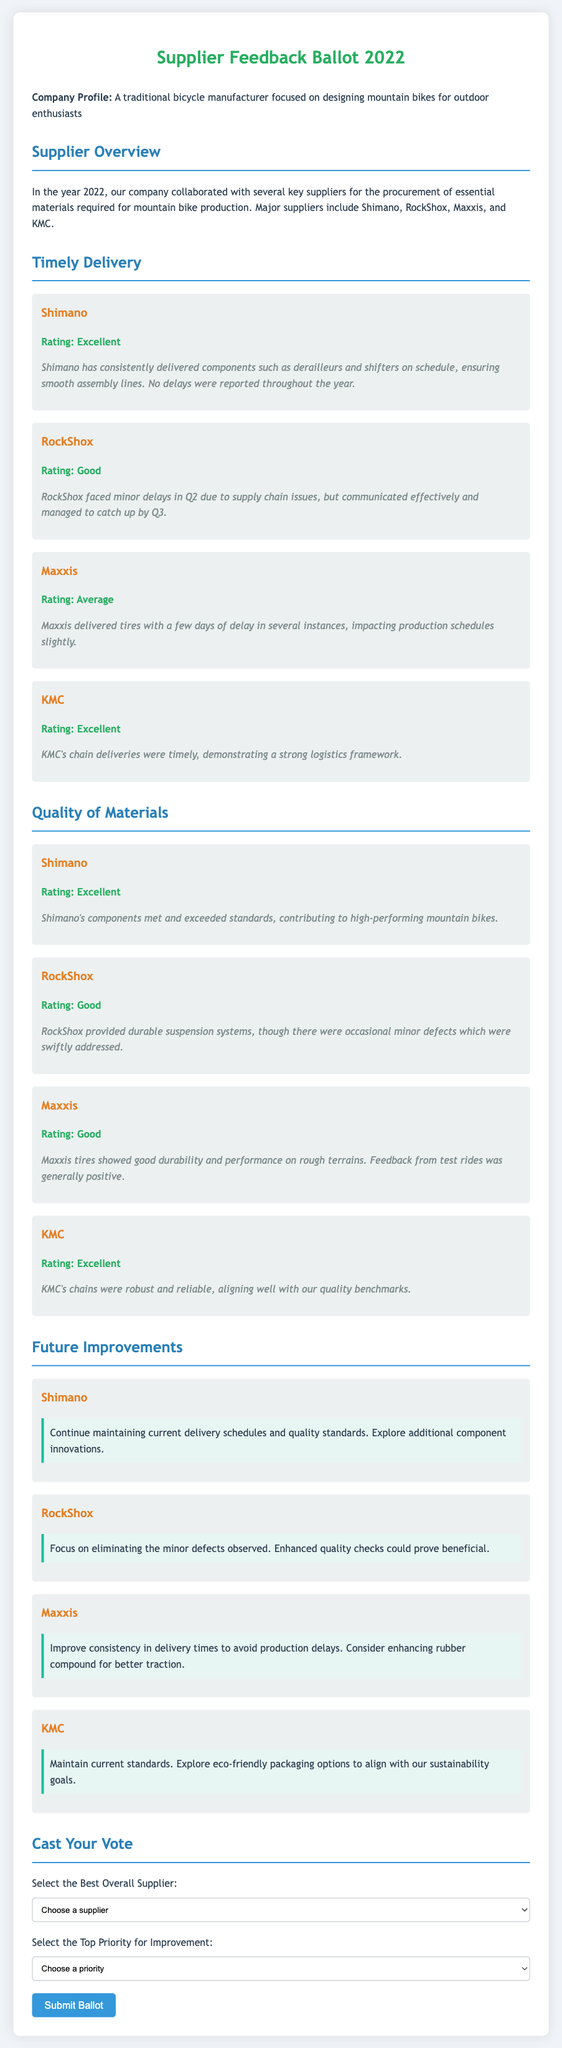what is the title of the document? The title is prominently displayed at the top of the document, indicating the contents.
Answer: Supplier Feedback Ballot 2022 who is the best-rated supplier for timely delivery? The document outlines ratings for each supplier's timely delivery.
Answer: Shimano what rating did RockShox receive for quality of materials? The document provides specific ratings for each supplier regarding the quality of materials.
Answer: Good which supplier faced minor delays in delivery? The document describes the experiences of each supplier, including any delays they encountered.
Answer: RockShox what is the suggested improvement for Maxxis? The document includes suggestions for each supplier regarding future improvements.
Answer: Improve consistency in delivery times how many main suppliers are mentioned in the document? The document lists all key suppliers, giving a clear count of those referenced.
Answer: Four what is the overall feedback for KMC's chains? The document summarizes the performance and quality of KMC's products directly.
Answer: Robust and reliable what is the focus of the company represented in the document? The introduction states the company's area of expertise and target audience.
Answer: Mountain bikes for outdoor enthusiasts 